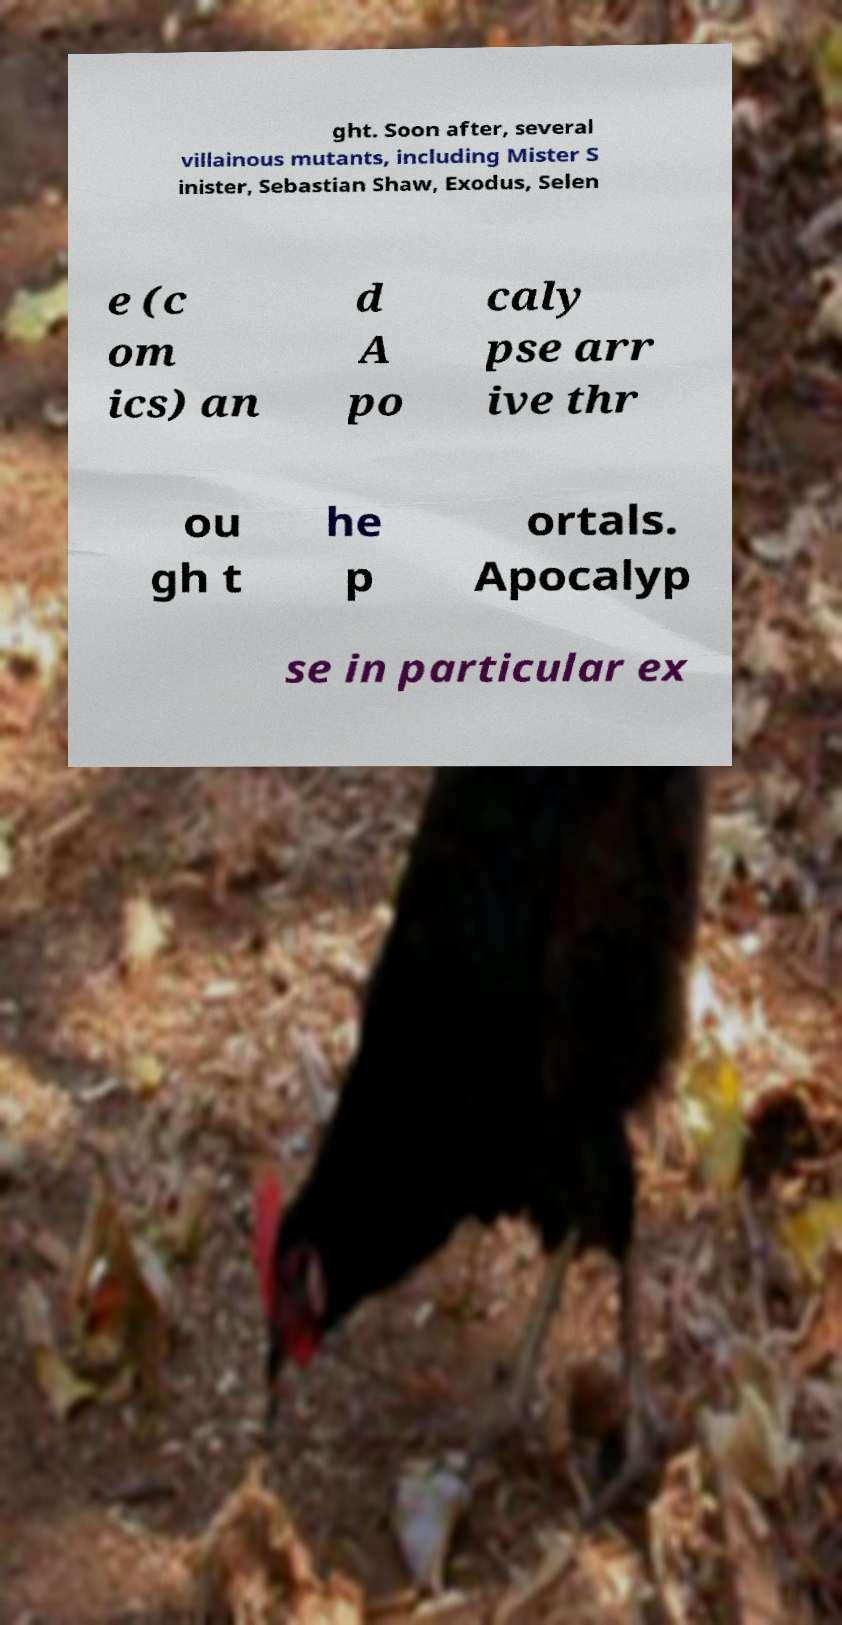Can you read and provide the text displayed in the image?This photo seems to have some interesting text. Can you extract and type it out for me? ght. Soon after, several villainous mutants, including Mister S inister, Sebastian Shaw, Exodus, Selen e (c om ics) an d A po caly pse arr ive thr ou gh t he p ortals. Apocalyp se in particular ex 